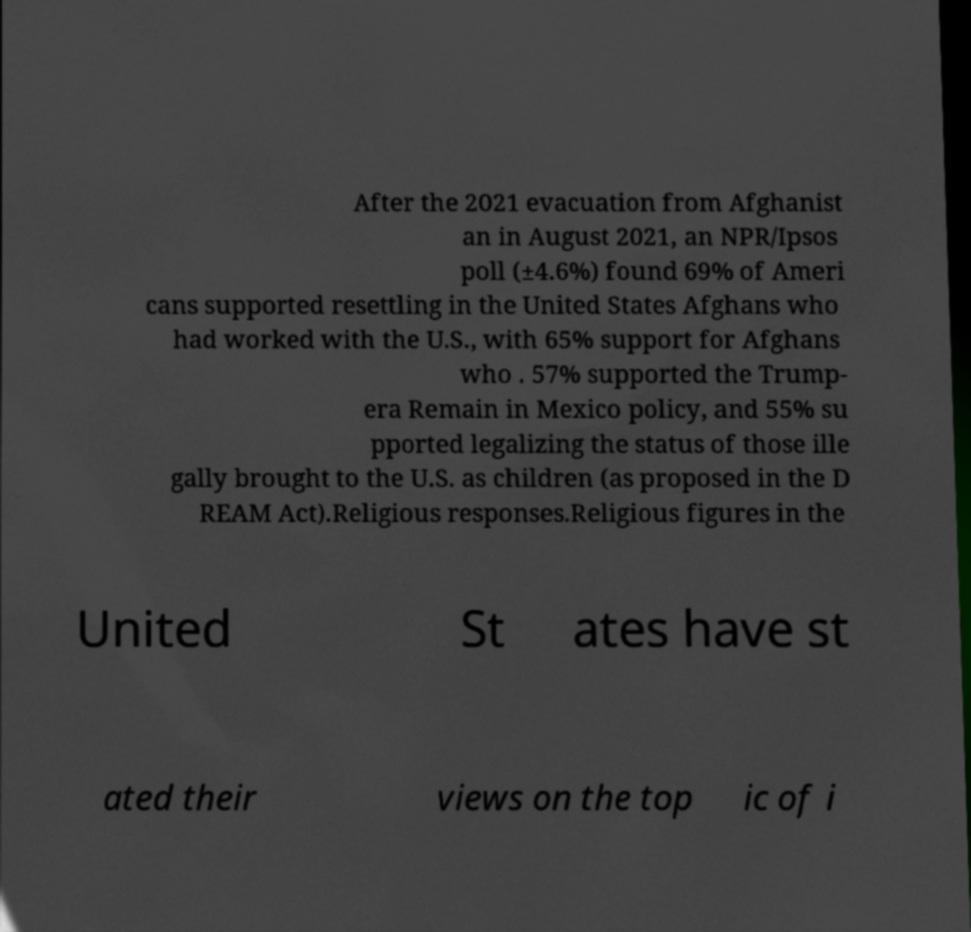Can you read and provide the text displayed in the image?This photo seems to have some interesting text. Can you extract and type it out for me? After the 2021 evacuation from Afghanist an in August 2021, an NPR/Ipsos poll (±4.6%) found 69% of Ameri cans supported resettling in the United States Afghans who had worked with the U.S., with 65% support for Afghans who . 57% supported the Trump- era Remain in Mexico policy, and 55% su pported legalizing the status of those ille gally brought to the U.S. as children (as proposed in the D REAM Act).Religious responses.Religious figures in the United St ates have st ated their views on the top ic of i 